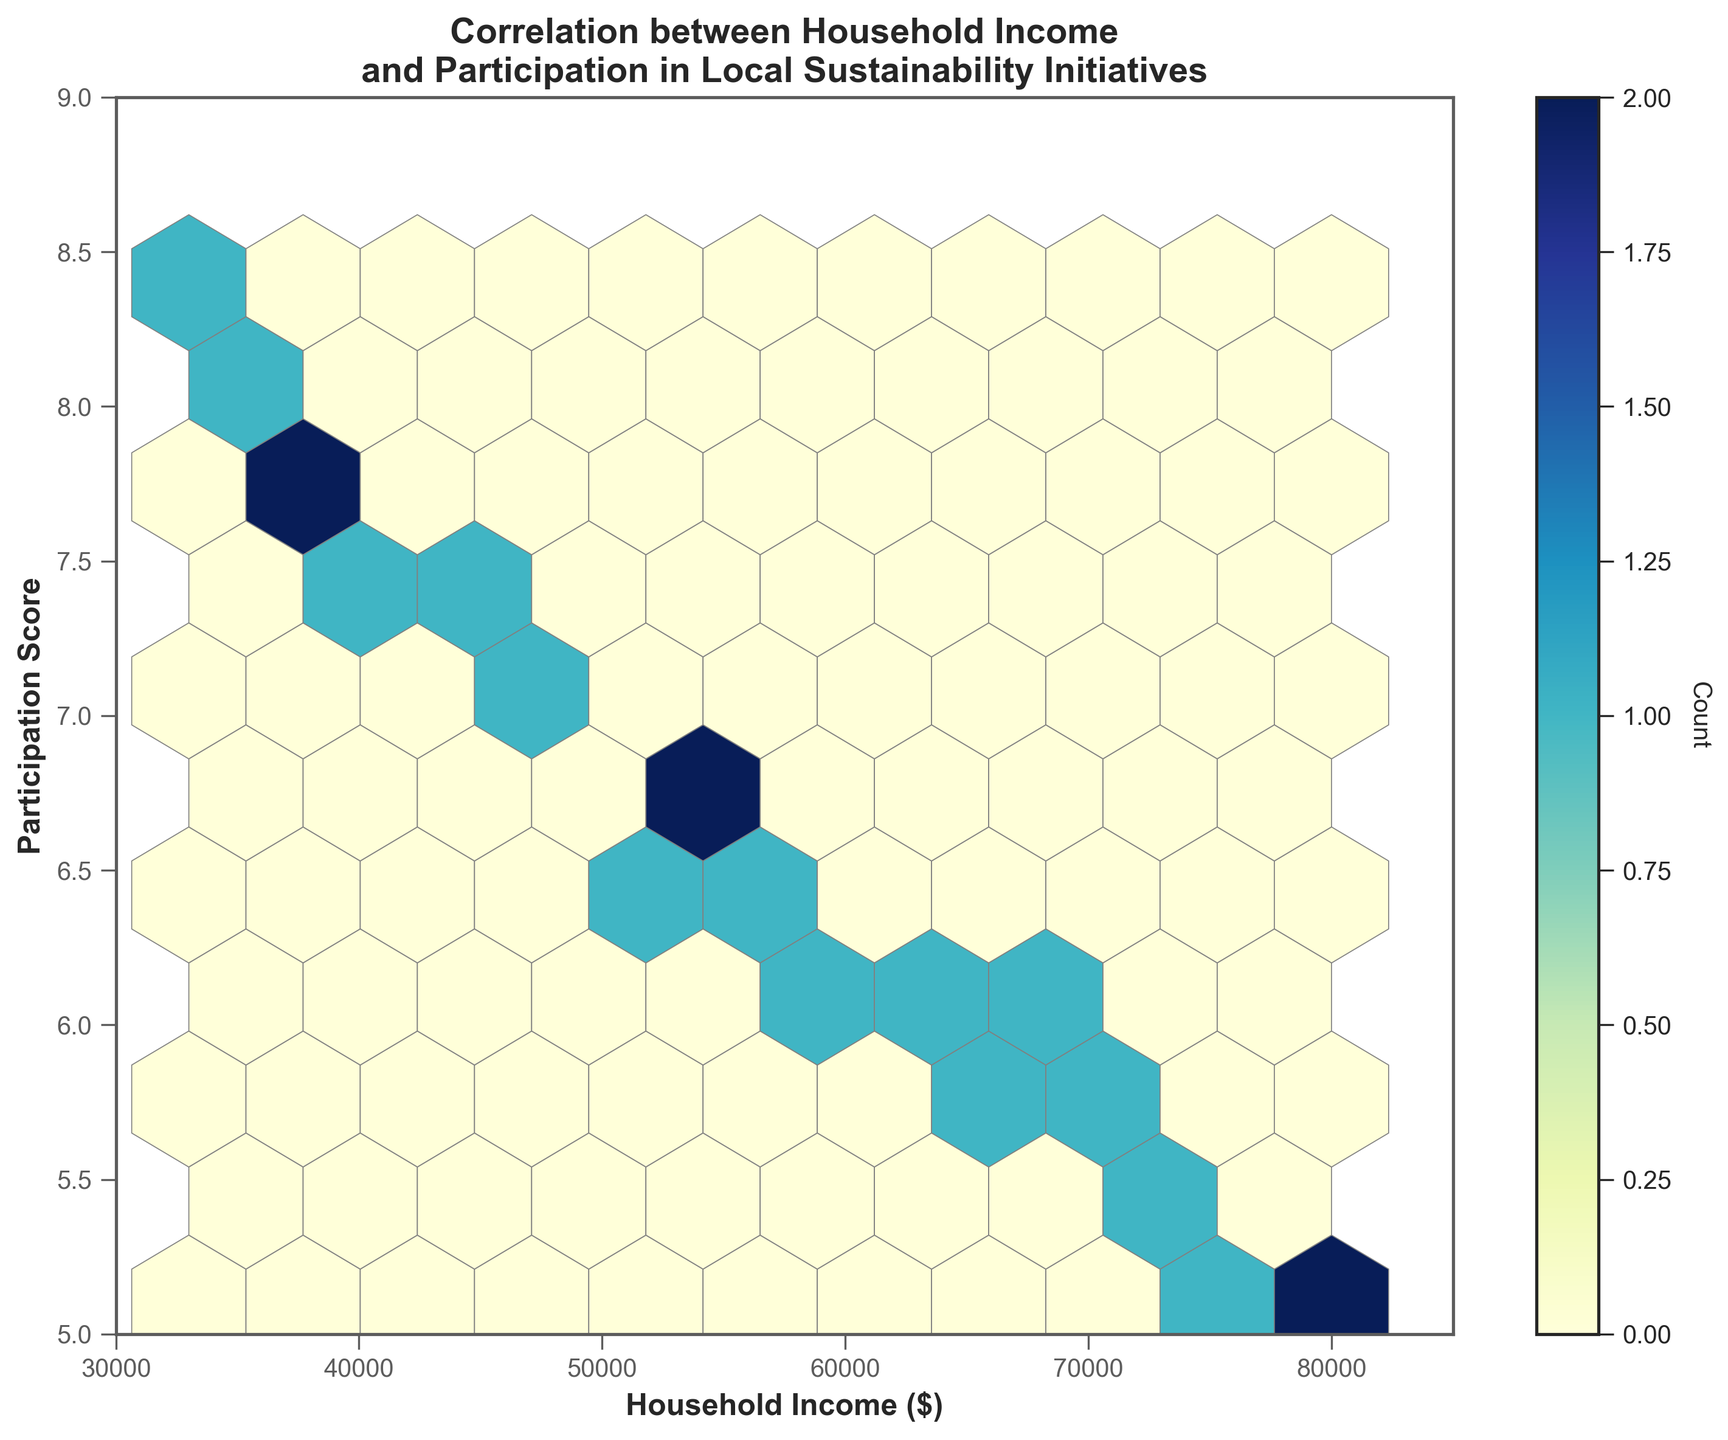What is the title of the plot? The title is located at the top of the plot and provides a summary of what the plot is about. Here, it mentions the correlation between household income and participation in local sustainability initiatives.
Answer: Correlation between Household Income and Participation in Local Sustainability Initiatives What value ranges are shown on the x and y axes? The x-axis range is indicated by the limits on the horizontal axis, and the y-axis range is indicated by the limits on the vertical axis.
Answer: x: 30000 to 85000, y: 5 to 9 What color represents the highest data density in the hexbin plot? In a hexbin plot, different colors represent different densities. By observing the color range in the color bar and the hexagons with the highest density, we see the color progression, with darker shades typically signifying higher densities.
Answer: Dark blue What does the color bar represent in the plot? The color bar is usually placed beside the plot, indicating what each color corresponds to in terms of data density – how many data points fall into each hexagon.
Answer: Count Which neighborhood has the highest household income and what is its participation score? By looking at the data points and matching them to their labels in the dataset, Panoramic Hill has the highest household income. The participation score associated with this income can be found from the data set.
Answer: Panoramic Hill, 5.1 Which neighborhood has the lowest participation score and what is its household income? By identifying the data points in the plot with the lowest y-value (participation score) and cross-referencing with the provided dataset, we can find this information.
Answer: Panoramic Hill, 80000 Is there an overall trend between household income and participation score? A trend in a hexbin plot can be inferred by looking at the general distribution of hexagons. If there is an observable pattern (e.g., upward or downward slope), it indicates a trend between the variables. From the figure, one can see a decreasing trend from left to right.
Answer: Decreasing trend What is the median household income among the displayed neighborhoods? To find the median household income, arrange all the household incomes in ascending order and identify the middle value. For 20 data points, the median will be the average of the 10th and 11th values.
Answer: 57000 Which participation score range has the highest density of data points? Examine the color bar and the plot to determine which hexagon color correlates with the highest density. Observe the participation score range in which this color predominantly appears.
Answer: 7.2 to 7.9 Is there any neighborhood with a high participation score but a low household income? By examining the hexagons with high y-values (participation scores) and cross-referencing with the dataset for low household incomes (lower x-values), we identify such neighborhoods. People's Park fits this description.
Answer: People's Park 